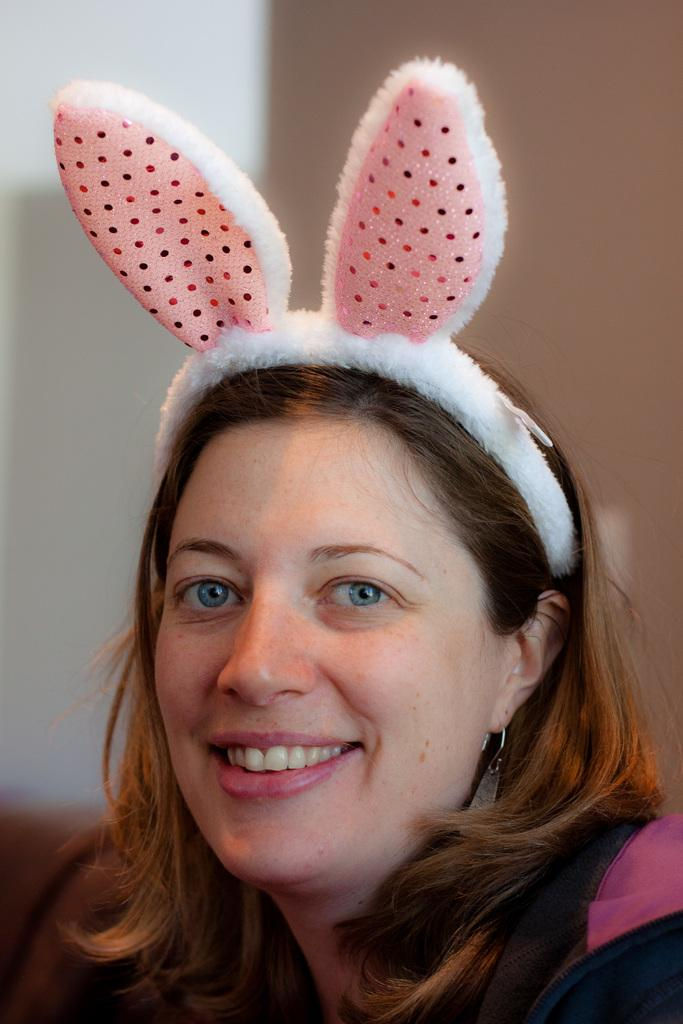Who is the main subject in the image? There is a lady in the image. What is the lady wearing on her head? The lady is wearing a bunny hat. What is the lady's facial expression in the image? The lady is smiling. What can be seen behind the lady in the image? There is a wall in the image. How would you describe the background of the image? The background of the image is blurred. What trick is the lady performing on the stage in the image? There is no stage or trick present in the image; it only features a lady wearing a bunny hat and smiling. 